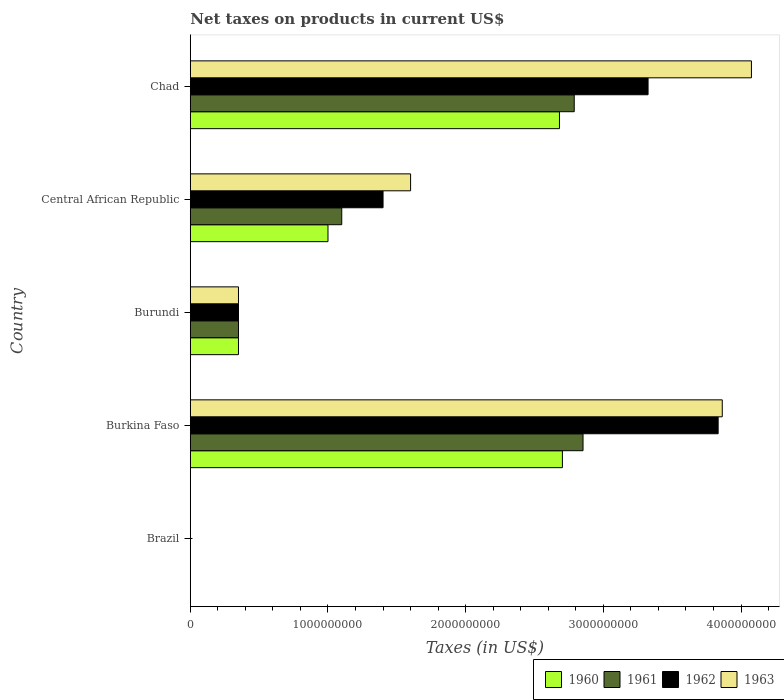How many different coloured bars are there?
Give a very brief answer. 4. Are the number of bars on each tick of the Y-axis equal?
Your response must be concise. Yes. What is the label of the 3rd group of bars from the top?
Offer a terse response. Burundi. In how many cases, is the number of bars for a given country not equal to the number of legend labels?
Your answer should be compact. 0. What is the net taxes on products in 1961 in Central African Republic?
Your answer should be compact. 1.10e+09. Across all countries, what is the maximum net taxes on products in 1962?
Offer a terse response. 3.83e+09. Across all countries, what is the minimum net taxes on products in 1961?
Make the answer very short. 0. In which country was the net taxes on products in 1963 maximum?
Provide a short and direct response. Chad. In which country was the net taxes on products in 1960 minimum?
Ensure brevity in your answer.  Brazil. What is the total net taxes on products in 1963 in the graph?
Your answer should be very brief. 9.89e+09. What is the difference between the net taxes on products in 1962 in Brazil and that in Central African Republic?
Your response must be concise. -1.40e+09. What is the difference between the net taxes on products in 1962 in Burundi and the net taxes on products in 1963 in Burkina Faso?
Offer a very short reply. -3.51e+09. What is the average net taxes on products in 1961 per country?
Your answer should be compact. 1.42e+09. What is the difference between the net taxes on products in 1960 and net taxes on products in 1961 in Chad?
Your answer should be very brief. -1.07e+08. In how many countries, is the net taxes on products in 1962 greater than 400000000 US$?
Your response must be concise. 3. What is the ratio of the net taxes on products in 1961 in Brazil to that in Burkina Faso?
Keep it short and to the point. 6.443132500283615e-14. Is the net taxes on products in 1961 in Burkina Faso less than that in Chad?
Offer a terse response. No. Is the difference between the net taxes on products in 1960 in Burkina Faso and Central African Republic greater than the difference between the net taxes on products in 1961 in Burkina Faso and Central African Republic?
Your answer should be very brief. No. What is the difference between the highest and the second highest net taxes on products in 1961?
Ensure brevity in your answer.  6.39e+07. What is the difference between the highest and the lowest net taxes on products in 1963?
Provide a short and direct response. 4.08e+09. In how many countries, is the net taxes on products in 1961 greater than the average net taxes on products in 1961 taken over all countries?
Ensure brevity in your answer.  2. What does the 2nd bar from the top in Central African Republic represents?
Give a very brief answer. 1962. How many bars are there?
Ensure brevity in your answer.  20. What is the difference between two consecutive major ticks on the X-axis?
Ensure brevity in your answer.  1.00e+09. Are the values on the major ticks of X-axis written in scientific E-notation?
Provide a short and direct response. No. Does the graph contain any zero values?
Keep it short and to the point. No. Does the graph contain grids?
Your answer should be compact. No. How many legend labels are there?
Your answer should be compact. 4. What is the title of the graph?
Give a very brief answer. Net taxes on products in current US$. Does "2009" appear as one of the legend labels in the graph?
Ensure brevity in your answer.  No. What is the label or title of the X-axis?
Provide a short and direct response. Taxes (in US$). What is the Taxes (in US$) of 1960 in Brazil?
Keep it short and to the point. 0. What is the Taxes (in US$) in 1961 in Brazil?
Your answer should be compact. 0. What is the Taxes (in US$) in 1962 in Brazil?
Ensure brevity in your answer.  0. What is the Taxes (in US$) in 1963 in Brazil?
Give a very brief answer. 0. What is the Taxes (in US$) of 1960 in Burkina Faso?
Make the answer very short. 2.70e+09. What is the Taxes (in US$) in 1961 in Burkina Faso?
Give a very brief answer. 2.85e+09. What is the Taxes (in US$) of 1962 in Burkina Faso?
Provide a short and direct response. 3.83e+09. What is the Taxes (in US$) in 1963 in Burkina Faso?
Ensure brevity in your answer.  3.86e+09. What is the Taxes (in US$) of 1960 in Burundi?
Your response must be concise. 3.50e+08. What is the Taxes (in US$) in 1961 in Burundi?
Give a very brief answer. 3.50e+08. What is the Taxes (in US$) in 1962 in Burundi?
Ensure brevity in your answer.  3.50e+08. What is the Taxes (in US$) in 1963 in Burundi?
Your answer should be very brief. 3.50e+08. What is the Taxes (in US$) of 1960 in Central African Republic?
Make the answer very short. 1.00e+09. What is the Taxes (in US$) of 1961 in Central African Republic?
Provide a succinct answer. 1.10e+09. What is the Taxes (in US$) in 1962 in Central African Republic?
Ensure brevity in your answer.  1.40e+09. What is the Taxes (in US$) of 1963 in Central African Republic?
Your answer should be very brief. 1.60e+09. What is the Taxes (in US$) in 1960 in Chad?
Your answer should be compact. 2.68e+09. What is the Taxes (in US$) of 1961 in Chad?
Offer a very short reply. 2.79e+09. What is the Taxes (in US$) of 1962 in Chad?
Your response must be concise. 3.32e+09. What is the Taxes (in US$) in 1963 in Chad?
Your answer should be very brief. 4.08e+09. Across all countries, what is the maximum Taxes (in US$) in 1960?
Your answer should be very brief. 2.70e+09. Across all countries, what is the maximum Taxes (in US$) in 1961?
Give a very brief answer. 2.85e+09. Across all countries, what is the maximum Taxes (in US$) in 1962?
Your answer should be very brief. 3.83e+09. Across all countries, what is the maximum Taxes (in US$) in 1963?
Offer a terse response. 4.08e+09. Across all countries, what is the minimum Taxes (in US$) of 1960?
Provide a short and direct response. 0. Across all countries, what is the minimum Taxes (in US$) of 1961?
Make the answer very short. 0. Across all countries, what is the minimum Taxes (in US$) of 1962?
Offer a terse response. 0. Across all countries, what is the minimum Taxes (in US$) in 1963?
Offer a terse response. 0. What is the total Taxes (in US$) in 1960 in the graph?
Offer a very short reply. 6.73e+09. What is the total Taxes (in US$) in 1961 in the graph?
Provide a short and direct response. 7.09e+09. What is the total Taxes (in US$) of 1962 in the graph?
Provide a succinct answer. 8.91e+09. What is the total Taxes (in US$) of 1963 in the graph?
Your response must be concise. 9.89e+09. What is the difference between the Taxes (in US$) of 1960 in Brazil and that in Burkina Faso?
Give a very brief answer. -2.70e+09. What is the difference between the Taxes (in US$) in 1961 in Brazil and that in Burkina Faso?
Keep it short and to the point. -2.85e+09. What is the difference between the Taxes (in US$) in 1962 in Brazil and that in Burkina Faso?
Your answer should be compact. -3.83e+09. What is the difference between the Taxes (in US$) in 1963 in Brazil and that in Burkina Faso?
Ensure brevity in your answer.  -3.86e+09. What is the difference between the Taxes (in US$) in 1960 in Brazil and that in Burundi?
Keep it short and to the point. -3.50e+08. What is the difference between the Taxes (in US$) of 1961 in Brazil and that in Burundi?
Your answer should be very brief. -3.50e+08. What is the difference between the Taxes (in US$) of 1962 in Brazil and that in Burundi?
Offer a terse response. -3.50e+08. What is the difference between the Taxes (in US$) of 1963 in Brazil and that in Burundi?
Make the answer very short. -3.50e+08. What is the difference between the Taxes (in US$) of 1960 in Brazil and that in Central African Republic?
Offer a terse response. -1.00e+09. What is the difference between the Taxes (in US$) of 1961 in Brazil and that in Central African Republic?
Provide a succinct answer. -1.10e+09. What is the difference between the Taxes (in US$) in 1962 in Brazil and that in Central African Republic?
Ensure brevity in your answer.  -1.40e+09. What is the difference between the Taxes (in US$) of 1963 in Brazil and that in Central African Republic?
Your response must be concise. -1.60e+09. What is the difference between the Taxes (in US$) in 1960 in Brazil and that in Chad?
Ensure brevity in your answer.  -2.68e+09. What is the difference between the Taxes (in US$) of 1961 in Brazil and that in Chad?
Ensure brevity in your answer.  -2.79e+09. What is the difference between the Taxes (in US$) of 1962 in Brazil and that in Chad?
Your answer should be very brief. -3.32e+09. What is the difference between the Taxes (in US$) of 1963 in Brazil and that in Chad?
Offer a very short reply. -4.08e+09. What is the difference between the Taxes (in US$) in 1960 in Burkina Faso and that in Burundi?
Make the answer very short. 2.35e+09. What is the difference between the Taxes (in US$) in 1961 in Burkina Faso and that in Burundi?
Offer a terse response. 2.50e+09. What is the difference between the Taxes (in US$) of 1962 in Burkina Faso and that in Burundi?
Ensure brevity in your answer.  3.48e+09. What is the difference between the Taxes (in US$) in 1963 in Burkina Faso and that in Burundi?
Offer a very short reply. 3.51e+09. What is the difference between the Taxes (in US$) in 1960 in Burkina Faso and that in Central African Republic?
Your answer should be very brief. 1.70e+09. What is the difference between the Taxes (in US$) in 1961 in Burkina Faso and that in Central African Republic?
Provide a succinct answer. 1.75e+09. What is the difference between the Taxes (in US$) of 1962 in Burkina Faso and that in Central African Republic?
Give a very brief answer. 2.43e+09. What is the difference between the Taxes (in US$) in 1963 in Burkina Faso and that in Central African Republic?
Offer a very short reply. 2.26e+09. What is the difference between the Taxes (in US$) of 1960 in Burkina Faso and that in Chad?
Provide a short and direct response. 2.13e+07. What is the difference between the Taxes (in US$) of 1961 in Burkina Faso and that in Chad?
Keep it short and to the point. 6.39e+07. What is the difference between the Taxes (in US$) in 1962 in Burkina Faso and that in Chad?
Give a very brief answer. 5.09e+08. What is the difference between the Taxes (in US$) of 1963 in Burkina Faso and that in Chad?
Your answer should be very brief. -2.12e+08. What is the difference between the Taxes (in US$) of 1960 in Burundi and that in Central African Republic?
Offer a terse response. -6.50e+08. What is the difference between the Taxes (in US$) in 1961 in Burundi and that in Central African Republic?
Ensure brevity in your answer.  -7.50e+08. What is the difference between the Taxes (in US$) of 1962 in Burundi and that in Central African Republic?
Your answer should be compact. -1.05e+09. What is the difference between the Taxes (in US$) in 1963 in Burundi and that in Central African Republic?
Your answer should be compact. -1.25e+09. What is the difference between the Taxes (in US$) of 1960 in Burundi and that in Chad?
Give a very brief answer. -2.33e+09. What is the difference between the Taxes (in US$) in 1961 in Burundi and that in Chad?
Provide a short and direct response. -2.44e+09. What is the difference between the Taxes (in US$) in 1962 in Burundi and that in Chad?
Keep it short and to the point. -2.97e+09. What is the difference between the Taxes (in US$) of 1963 in Burundi and that in Chad?
Your answer should be very brief. -3.73e+09. What is the difference between the Taxes (in US$) in 1960 in Central African Republic and that in Chad?
Offer a terse response. -1.68e+09. What is the difference between the Taxes (in US$) in 1961 in Central African Republic and that in Chad?
Ensure brevity in your answer.  -1.69e+09. What is the difference between the Taxes (in US$) of 1962 in Central African Republic and that in Chad?
Make the answer very short. -1.92e+09. What is the difference between the Taxes (in US$) in 1963 in Central African Republic and that in Chad?
Your answer should be compact. -2.48e+09. What is the difference between the Taxes (in US$) in 1960 in Brazil and the Taxes (in US$) in 1961 in Burkina Faso?
Make the answer very short. -2.85e+09. What is the difference between the Taxes (in US$) of 1960 in Brazil and the Taxes (in US$) of 1962 in Burkina Faso?
Give a very brief answer. -3.83e+09. What is the difference between the Taxes (in US$) of 1960 in Brazil and the Taxes (in US$) of 1963 in Burkina Faso?
Make the answer very short. -3.86e+09. What is the difference between the Taxes (in US$) of 1961 in Brazil and the Taxes (in US$) of 1962 in Burkina Faso?
Your response must be concise. -3.83e+09. What is the difference between the Taxes (in US$) of 1961 in Brazil and the Taxes (in US$) of 1963 in Burkina Faso?
Provide a succinct answer. -3.86e+09. What is the difference between the Taxes (in US$) in 1962 in Brazil and the Taxes (in US$) in 1963 in Burkina Faso?
Make the answer very short. -3.86e+09. What is the difference between the Taxes (in US$) in 1960 in Brazil and the Taxes (in US$) in 1961 in Burundi?
Offer a very short reply. -3.50e+08. What is the difference between the Taxes (in US$) of 1960 in Brazil and the Taxes (in US$) of 1962 in Burundi?
Your answer should be very brief. -3.50e+08. What is the difference between the Taxes (in US$) in 1960 in Brazil and the Taxes (in US$) in 1963 in Burundi?
Give a very brief answer. -3.50e+08. What is the difference between the Taxes (in US$) in 1961 in Brazil and the Taxes (in US$) in 1962 in Burundi?
Make the answer very short. -3.50e+08. What is the difference between the Taxes (in US$) in 1961 in Brazil and the Taxes (in US$) in 1963 in Burundi?
Ensure brevity in your answer.  -3.50e+08. What is the difference between the Taxes (in US$) in 1962 in Brazil and the Taxes (in US$) in 1963 in Burundi?
Give a very brief answer. -3.50e+08. What is the difference between the Taxes (in US$) of 1960 in Brazil and the Taxes (in US$) of 1961 in Central African Republic?
Offer a terse response. -1.10e+09. What is the difference between the Taxes (in US$) of 1960 in Brazil and the Taxes (in US$) of 1962 in Central African Republic?
Ensure brevity in your answer.  -1.40e+09. What is the difference between the Taxes (in US$) of 1960 in Brazil and the Taxes (in US$) of 1963 in Central African Republic?
Provide a short and direct response. -1.60e+09. What is the difference between the Taxes (in US$) of 1961 in Brazil and the Taxes (in US$) of 1962 in Central African Republic?
Offer a terse response. -1.40e+09. What is the difference between the Taxes (in US$) of 1961 in Brazil and the Taxes (in US$) of 1963 in Central African Republic?
Your answer should be compact. -1.60e+09. What is the difference between the Taxes (in US$) of 1962 in Brazil and the Taxes (in US$) of 1963 in Central African Republic?
Provide a succinct answer. -1.60e+09. What is the difference between the Taxes (in US$) of 1960 in Brazil and the Taxes (in US$) of 1961 in Chad?
Give a very brief answer. -2.79e+09. What is the difference between the Taxes (in US$) of 1960 in Brazil and the Taxes (in US$) of 1962 in Chad?
Your answer should be very brief. -3.32e+09. What is the difference between the Taxes (in US$) in 1960 in Brazil and the Taxes (in US$) in 1963 in Chad?
Your response must be concise. -4.08e+09. What is the difference between the Taxes (in US$) of 1961 in Brazil and the Taxes (in US$) of 1962 in Chad?
Your answer should be compact. -3.32e+09. What is the difference between the Taxes (in US$) in 1961 in Brazil and the Taxes (in US$) in 1963 in Chad?
Provide a succinct answer. -4.08e+09. What is the difference between the Taxes (in US$) in 1962 in Brazil and the Taxes (in US$) in 1963 in Chad?
Your answer should be very brief. -4.08e+09. What is the difference between the Taxes (in US$) in 1960 in Burkina Faso and the Taxes (in US$) in 1961 in Burundi?
Offer a terse response. 2.35e+09. What is the difference between the Taxes (in US$) of 1960 in Burkina Faso and the Taxes (in US$) of 1962 in Burundi?
Give a very brief answer. 2.35e+09. What is the difference between the Taxes (in US$) of 1960 in Burkina Faso and the Taxes (in US$) of 1963 in Burundi?
Ensure brevity in your answer.  2.35e+09. What is the difference between the Taxes (in US$) in 1961 in Burkina Faso and the Taxes (in US$) in 1962 in Burundi?
Your answer should be compact. 2.50e+09. What is the difference between the Taxes (in US$) of 1961 in Burkina Faso and the Taxes (in US$) of 1963 in Burundi?
Offer a terse response. 2.50e+09. What is the difference between the Taxes (in US$) of 1962 in Burkina Faso and the Taxes (in US$) of 1963 in Burundi?
Make the answer very short. 3.48e+09. What is the difference between the Taxes (in US$) of 1960 in Burkina Faso and the Taxes (in US$) of 1961 in Central African Republic?
Make the answer very short. 1.60e+09. What is the difference between the Taxes (in US$) in 1960 in Burkina Faso and the Taxes (in US$) in 1962 in Central African Republic?
Offer a very short reply. 1.30e+09. What is the difference between the Taxes (in US$) of 1960 in Burkina Faso and the Taxes (in US$) of 1963 in Central African Republic?
Provide a succinct answer. 1.10e+09. What is the difference between the Taxes (in US$) of 1961 in Burkina Faso and the Taxes (in US$) of 1962 in Central African Republic?
Offer a terse response. 1.45e+09. What is the difference between the Taxes (in US$) in 1961 in Burkina Faso and the Taxes (in US$) in 1963 in Central African Republic?
Offer a very short reply. 1.25e+09. What is the difference between the Taxes (in US$) of 1962 in Burkina Faso and the Taxes (in US$) of 1963 in Central African Republic?
Ensure brevity in your answer.  2.23e+09. What is the difference between the Taxes (in US$) of 1960 in Burkina Faso and the Taxes (in US$) of 1961 in Chad?
Your answer should be compact. -8.59e+07. What is the difference between the Taxes (in US$) in 1960 in Burkina Faso and the Taxes (in US$) in 1962 in Chad?
Keep it short and to the point. -6.22e+08. What is the difference between the Taxes (in US$) of 1960 in Burkina Faso and the Taxes (in US$) of 1963 in Chad?
Offer a very short reply. -1.37e+09. What is the difference between the Taxes (in US$) in 1961 in Burkina Faso and the Taxes (in US$) in 1962 in Chad?
Provide a short and direct response. -4.72e+08. What is the difference between the Taxes (in US$) in 1961 in Burkina Faso and the Taxes (in US$) in 1963 in Chad?
Give a very brief answer. -1.22e+09. What is the difference between the Taxes (in US$) of 1962 in Burkina Faso and the Taxes (in US$) of 1963 in Chad?
Make the answer very short. -2.42e+08. What is the difference between the Taxes (in US$) of 1960 in Burundi and the Taxes (in US$) of 1961 in Central African Republic?
Your answer should be very brief. -7.50e+08. What is the difference between the Taxes (in US$) in 1960 in Burundi and the Taxes (in US$) in 1962 in Central African Republic?
Ensure brevity in your answer.  -1.05e+09. What is the difference between the Taxes (in US$) of 1960 in Burundi and the Taxes (in US$) of 1963 in Central African Republic?
Your response must be concise. -1.25e+09. What is the difference between the Taxes (in US$) of 1961 in Burundi and the Taxes (in US$) of 1962 in Central African Republic?
Offer a terse response. -1.05e+09. What is the difference between the Taxes (in US$) in 1961 in Burundi and the Taxes (in US$) in 1963 in Central African Republic?
Your answer should be compact. -1.25e+09. What is the difference between the Taxes (in US$) of 1962 in Burundi and the Taxes (in US$) of 1963 in Central African Republic?
Your response must be concise. -1.25e+09. What is the difference between the Taxes (in US$) in 1960 in Burundi and the Taxes (in US$) in 1961 in Chad?
Your response must be concise. -2.44e+09. What is the difference between the Taxes (in US$) of 1960 in Burundi and the Taxes (in US$) of 1962 in Chad?
Provide a succinct answer. -2.97e+09. What is the difference between the Taxes (in US$) in 1960 in Burundi and the Taxes (in US$) in 1963 in Chad?
Give a very brief answer. -3.73e+09. What is the difference between the Taxes (in US$) of 1961 in Burundi and the Taxes (in US$) of 1962 in Chad?
Provide a short and direct response. -2.97e+09. What is the difference between the Taxes (in US$) in 1961 in Burundi and the Taxes (in US$) in 1963 in Chad?
Ensure brevity in your answer.  -3.73e+09. What is the difference between the Taxes (in US$) in 1962 in Burundi and the Taxes (in US$) in 1963 in Chad?
Offer a terse response. -3.73e+09. What is the difference between the Taxes (in US$) of 1960 in Central African Republic and the Taxes (in US$) of 1961 in Chad?
Offer a terse response. -1.79e+09. What is the difference between the Taxes (in US$) of 1960 in Central African Republic and the Taxes (in US$) of 1962 in Chad?
Give a very brief answer. -2.32e+09. What is the difference between the Taxes (in US$) of 1960 in Central African Republic and the Taxes (in US$) of 1963 in Chad?
Offer a terse response. -3.08e+09. What is the difference between the Taxes (in US$) of 1961 in Central African Republic and the Taxes (in US$) of 1962 in Chad?
Keep it short and to the point. -2.22e+09. What is the difference between the Taxes (in US$) in 1961 in Central African Republic and the Taxes (in US$) in 1963 in Chad?
Offer a very short reply. -2.98e+09. What is the difference between the Taxes (in US$) in 1962 in Central African Republic and the Taxes (in US$) in 1963 in Chad?
Keep it short and to the point. -2.68e+09. What is the average Taxes (in US$) in 1960 per country?
Your response must be concise. 1.35e+09. What is the average Taxes (in US$) of 1961 per country?
Your answer should be compact. 1.42e+09. What is the average Taxes (in US$) in 1962 per country?
Provide a succinct answer. 1.78e+09. What is the average Taxes (in US$) in 1963 per country?
Provide a short and direct response. 1.98e+09. What is the difference between the Taxes (in US$) in 1960 and Taxes (in US$) in 1962 in Brazil?
Ensure brevity in your answer.  -0. What is the difference between the Taxes (in US$) in 1960 and Taxes (in US$) in 1963 in Brazil?
Make the answer very short. -0. What is the difference between the Taxes (in US$) in 1961 and Taxes (in US$) in 1962 in Brazil?
Give a very brief answer. -0. What is the difference between the Taxes (in US$) of 1961 and Taxes (in US$) of 1963 in Brazil?
Provide a succinct answer. -0. What is the difference between the Taxes (in US$) of 1962 and Taxes (in US$) of 1963 in Brazil?
Keep it short and to the point. -0. What is the difference between the Taxes (in US$) in 1960 and Taxes (in US$) in 1961 in Burkina Faso?
Your answer should be compact. -1.50e+08. What is the difference between the Taxes (in US$) in 1960 and Taxes (in US$) in 1962 in Burkina Faso?
Your answer should be compact. -1.13e+09. What is the difference between the Taxes (in US$) in 1960 and Taxes (in US$) in 1963 in Burkina Faso?
Offer a terse response. -1.16e+09. What is the difference between the Taxes (in US$) in 1961 and Taxes (in US$) in 1962 in Burkina Faso?
Give a very brief answer. -9.81e+08. What is the difference between the Taxes (in US$) in 1961 and Taxes (in US$) in 1963 in Burkina Faso?
Offer a terse response. -1.01e+09. What is the difference between the Taxes (in US$) of 1962 and Taxes (in US$) of 1963 in Burkina Faso?
Your answer should be very brief. -3.00e+07. What is the difference between the Taxes (in US$) in 1961 and Taxes (in US$) in 1962 in Burundi?
Your response must be concise. 0. What is the difference between the Taxes (in US$) of 1961 and Taxes (in US$) of 1963 in Burundi?
Provide a succinct answer. 0. What is the difference between the Taxes (in US$) of 1962 and Taxes (in US$) of 1963 in Burundi?
Provide a short and direct response. 0. What is the difference between the Taxes (in US$) in 1960 and Taxes (in US$) in 1961 in Central African Republic?
Ensure brevity in your answer.  -1.00e+08. What is the difference between the Taxes (in US$) of 1960 and Taxes (in US$) of 1962 in Central African Republic?
Make the answer very short. -4.00e+08. What is the difference between the Taxes (in US$) of 1960 and Taxes (in US$) of 1963 in Central African Republic?
Offer a very short reply. -6.00e+08. What is the difference between the Taxes (in US$) in 1961 and Taxes (in US$) in 1962 in Central African Republic?
Provide a succinct answer. -3.00e+08. What is the difference between the Taxes (in US$) in 1961 and Taxes (in US$) in 1963 in Central African Republic?
Give a very brief answer. -5.00e+08. What is the difference between the Taxes (in US$) in 1962 and Taxes (in US$) in 1963 in Central African Republic?
Ensure brevity in your answer.  -2.00e+08. What is the difference between the Taxes (in US$) of 1960 and Taxes (in US$) of 1961 in Chad?
Keep it short and to the point. -1.07e+08. What is the difference between the Taxes (in US$) of 1960 and Taxes (in US$) of 1962 in Chad?
Give a very brief answer. -6.44e+08. What is the difference between the Taxes (in US$) of 1960 and Taxes (in US$) of 1963 in Chad?
Make the answer very short. -1.39e+09. What is the difference between the Taxes (in US$) in 1961 and Taxes (in US$) in 1962 in Chad?
Your answer should be very brief. -5.36e+08. What is the difference between the Taxes (in US$) in 1961 and Taxes (in US$) in 1963 in Chad?
Provide a short and direct response. -1.29e+09. What is the difference between the Taxes (in US$) of 1962 and Taxes (in US$) of 1963 in Chad?
Your answer should be very brief. -7.51e+08. What is the ratio of the Taxes (in US$) in 1960 in Brazil to that in Burkina Faso?
Offer a terse response. 0. What is the ratio of the Taxes (in US$) of 1961 in Brazil to that in Burkina Faso?
Your answer should be very brief. 0. What is the ratio of the Taxes (in US$) in 1961 in Brazil to that in Burundi?
Offer a terse response. 0. What is the ratio of the Taxes (in US$) of 1963 in Brazil to that in Burundi?
Offer a terse response. 0. What is the ratio of the Taxes (in US$) of 1960 in Brazil to that in Central African Republic?
Ensure brevity in your answer.  0. What is the ratio of the Taxes (in US$) in 1961 in Brazil to that in Central African Republic?
Your answer should be compact. 0. What is the ratio of the Taxes (in US$) in 1960 in Burkina Faso to that in Burundi?
Ensure brevity in your answer.  7.72. What is the ratio of the Taxes (in US$) of 1961 in Burkina Faso to that in Burundi?
Your answer should be compact. 8.15. What is the ratio of the Taxes (in US$) in 1962 in Burkina Faso to that in Burundi?
Your answer should be very brief. 10.95. What is the ratio of the Taxes (in US$) of 1963 in Burkina Faso to that in Burundi?
Keep it short and to the point. 11.04. What is the ratio of the Taxes (in US$) of 1960 in Burkina Faso to that in Central African Republic?
Give a very brief answer. 2.7. What is the ratio of the Taxes (in US$) of 1961 in Burkina Faso to that in Central African Republic?
Your response must be concise. 2.59. What is the ratio of the Taxes (in US$) of 1962 in Burkina Faso to that in Central African Republic?
Provide a short and direct response. 2.74. What is the ratio of the Taxes (in US$) in 1963 in Burkina Faso to that in Central African Republic?
Provide a short and direct response. 2.41. What is the ratio of the Taxes (in US$) of 1961 in Burkina Faso to that in Chad?
Your answer should be compact. 1.02. What is the ratio of the Taxes (in US$) of 1962 in Burkina Faso to that in Chad?
Keep it short and to the point. 1.15. What is the ratio of the Taxes (in US$) in 1963 in Burkina Faso to that in Chad?
Your response must be concise. 0.95. What is the ratio of the Taxes (in US$) in 1960 in Burundi to that in Central African Republic?
Your answer should be compact. 0.35. What is the ratio of the Taxes (in US$) in 1961 in Burundi to that in Central African Republic?
Give a very brief answer. 0.32. What is the ratio of the Taxes (in US$) of 1963 in Burundi to that in Central African Republic?
Offer a very short reply. 0.22. What is the ratio of the Taxes (in US$) in 1960 in Burundi to that in Chad?
Your answer should be very brief. 0.13. What is the ratio of the Taxes (in US$) of 1961 in Burundi to that in Chad?
Give a very brief answer. 0.13. What is the ratio of the Taxes (in US$) of 1962 in Burundi to that in Chad?
Your answer should be compact. 0.11. What is the ratio of the Taxes (in US$) in 1963 in Burundi to that in Chad?
Offer a terse response. 0.09. What is the ratio of the Taxes (in US$) of 1960 in Central African Republic to that in Chad?
Your answer should be very brief. 0.37. What is the ratio of the Taxes (in US$) in 1961 in Central African Republic to that in Chad?
Make the answer very short. 0.39. What is the ratio of the Taxes (in US$) in 1962 in Central African Republic to that in Chad?
Make the answer very short. 0.42. What is the ratio of the Taxes (in US$) of 1963 in Central African Republic to that in Chad?
Provide a succinct answer. 0.39. What is the difference between the highest and the second highest Taxes (in US$) in 1960?
Your response must be concise. 2.13e+07. What is the difference between the highest and the second highest Taxes (in US$) in 1961?
Your answer should be compact. 6.39e+07. What is the difference between the highest and the second highest Taxes (in US$) of 1962?
Make the answer very short. 5.09e+08. What is the difference between the highest and the second highest Taxes (in US$) of 1963?
Your answer should be compact. 2.12e+08. What is the difference between the highest and the lowest Taxes (in US$) in 1960?
Your answer should be compact. 2.70e+09. What is the difference between the highest and the lowest Taxes (in US$) of 1961?
Provide a succinct answer. 2.85e+09. What is the difference between the highest and the lowest Taxes (in US$) of 1962?
Give a very brief answer. 3.83e+09. What is the difference between the highest and the lowest Taxes (in US$) in 1963?
Give a very brief answer. 4.08e+09. 